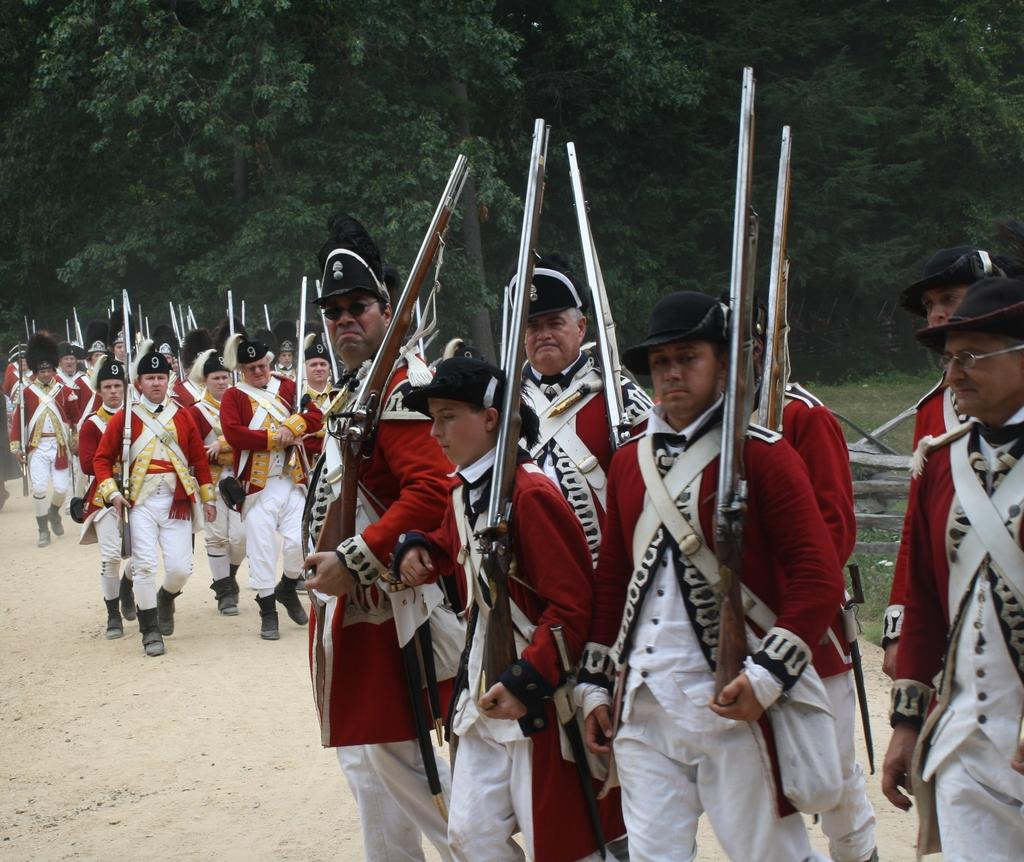Where was the image taken? The image was clicked outside. What can be seen in the image? There is a group of people in the image. What are the people wearing? The people are wearing uniforms. What are the people holding? The people are holding rifles. What can be seen in the background of the image? There are trees and other objects visible in the background of the image. Can you see any screws connecting the trees in the image? There are no screws or connections visible between the trees in the image; they are separate entities in the background. 